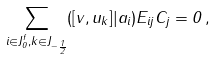<formula> <loc_0><loc_0><loc_500><loc_500>\sum _ { i \in J _ { 0 } ^ { f } , k \in J _ { - \frac { 1 } { 2 } } } ( [ v , u _ { k } ] | a _ { i } ) E _ { i j } C _ { j } = 0 \, ,</formula> 